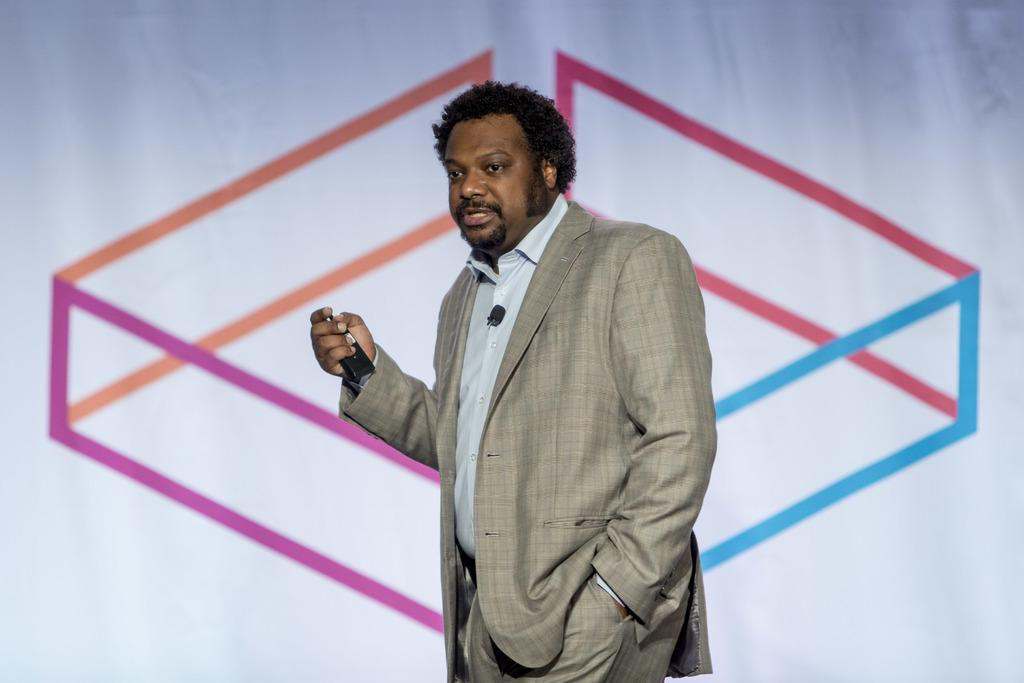What can be seen in the image? There is a person in the image. What is the person wearing? The person is wearing a gray color suit. What is the person holding? The person is holding a device. What is the person doing with the device? The person is speaking. What is visible in the background of the image? There is a painting in the background of the image. What is the color of the surface on which the painting is placed? The painting is on a white colored surface. Can you see any veins in the person's hand in the image? There is no visible indication of veins in the person's hand in the image. Is the person whistling while speaking in the image? There is no indication of whistling in the image; the person is only speaking. 